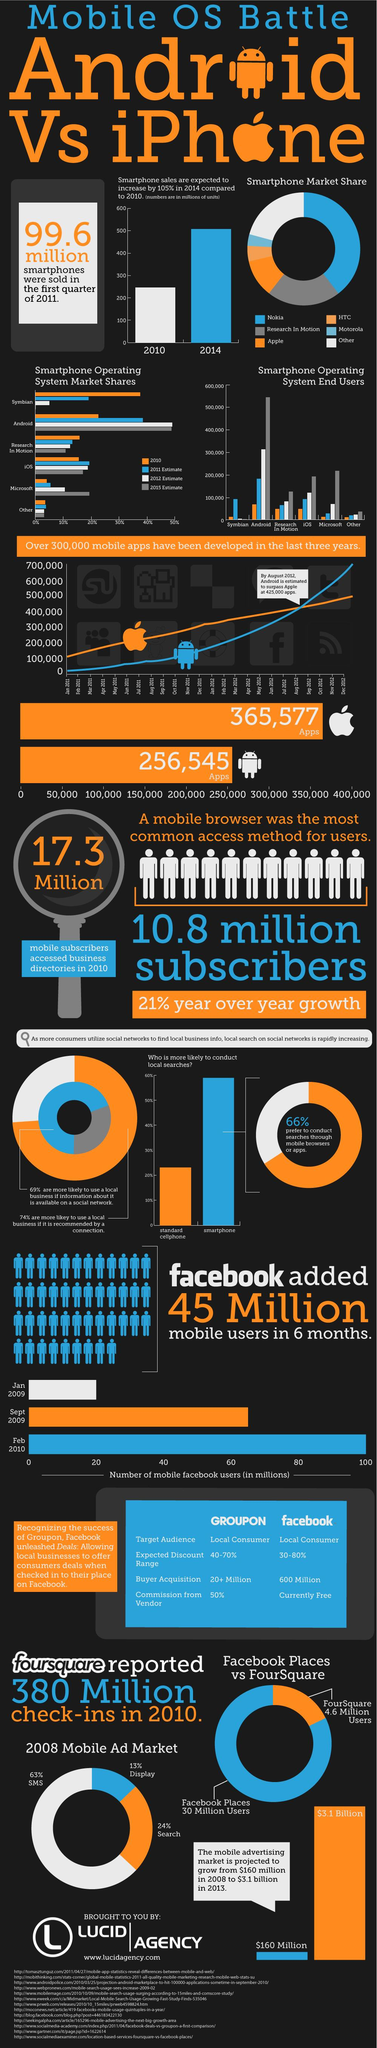List a handful of essential elements in this visual. In 2015, the Android operating system held the highest market share among smartphone operating systems. In 2010, mobile subscribers accessed business directories in large numbers, with a total of 17.3 million individuals using this service. In 2010, Symbian was the smartphone operating system that held the highest market share. In 2015, the Android operating system had over 500,000 end users, making it the smartphone operating system with the highest number of users at that time. As of February 2010, there were approximately 100 million mobile Facebook users worldwide. 